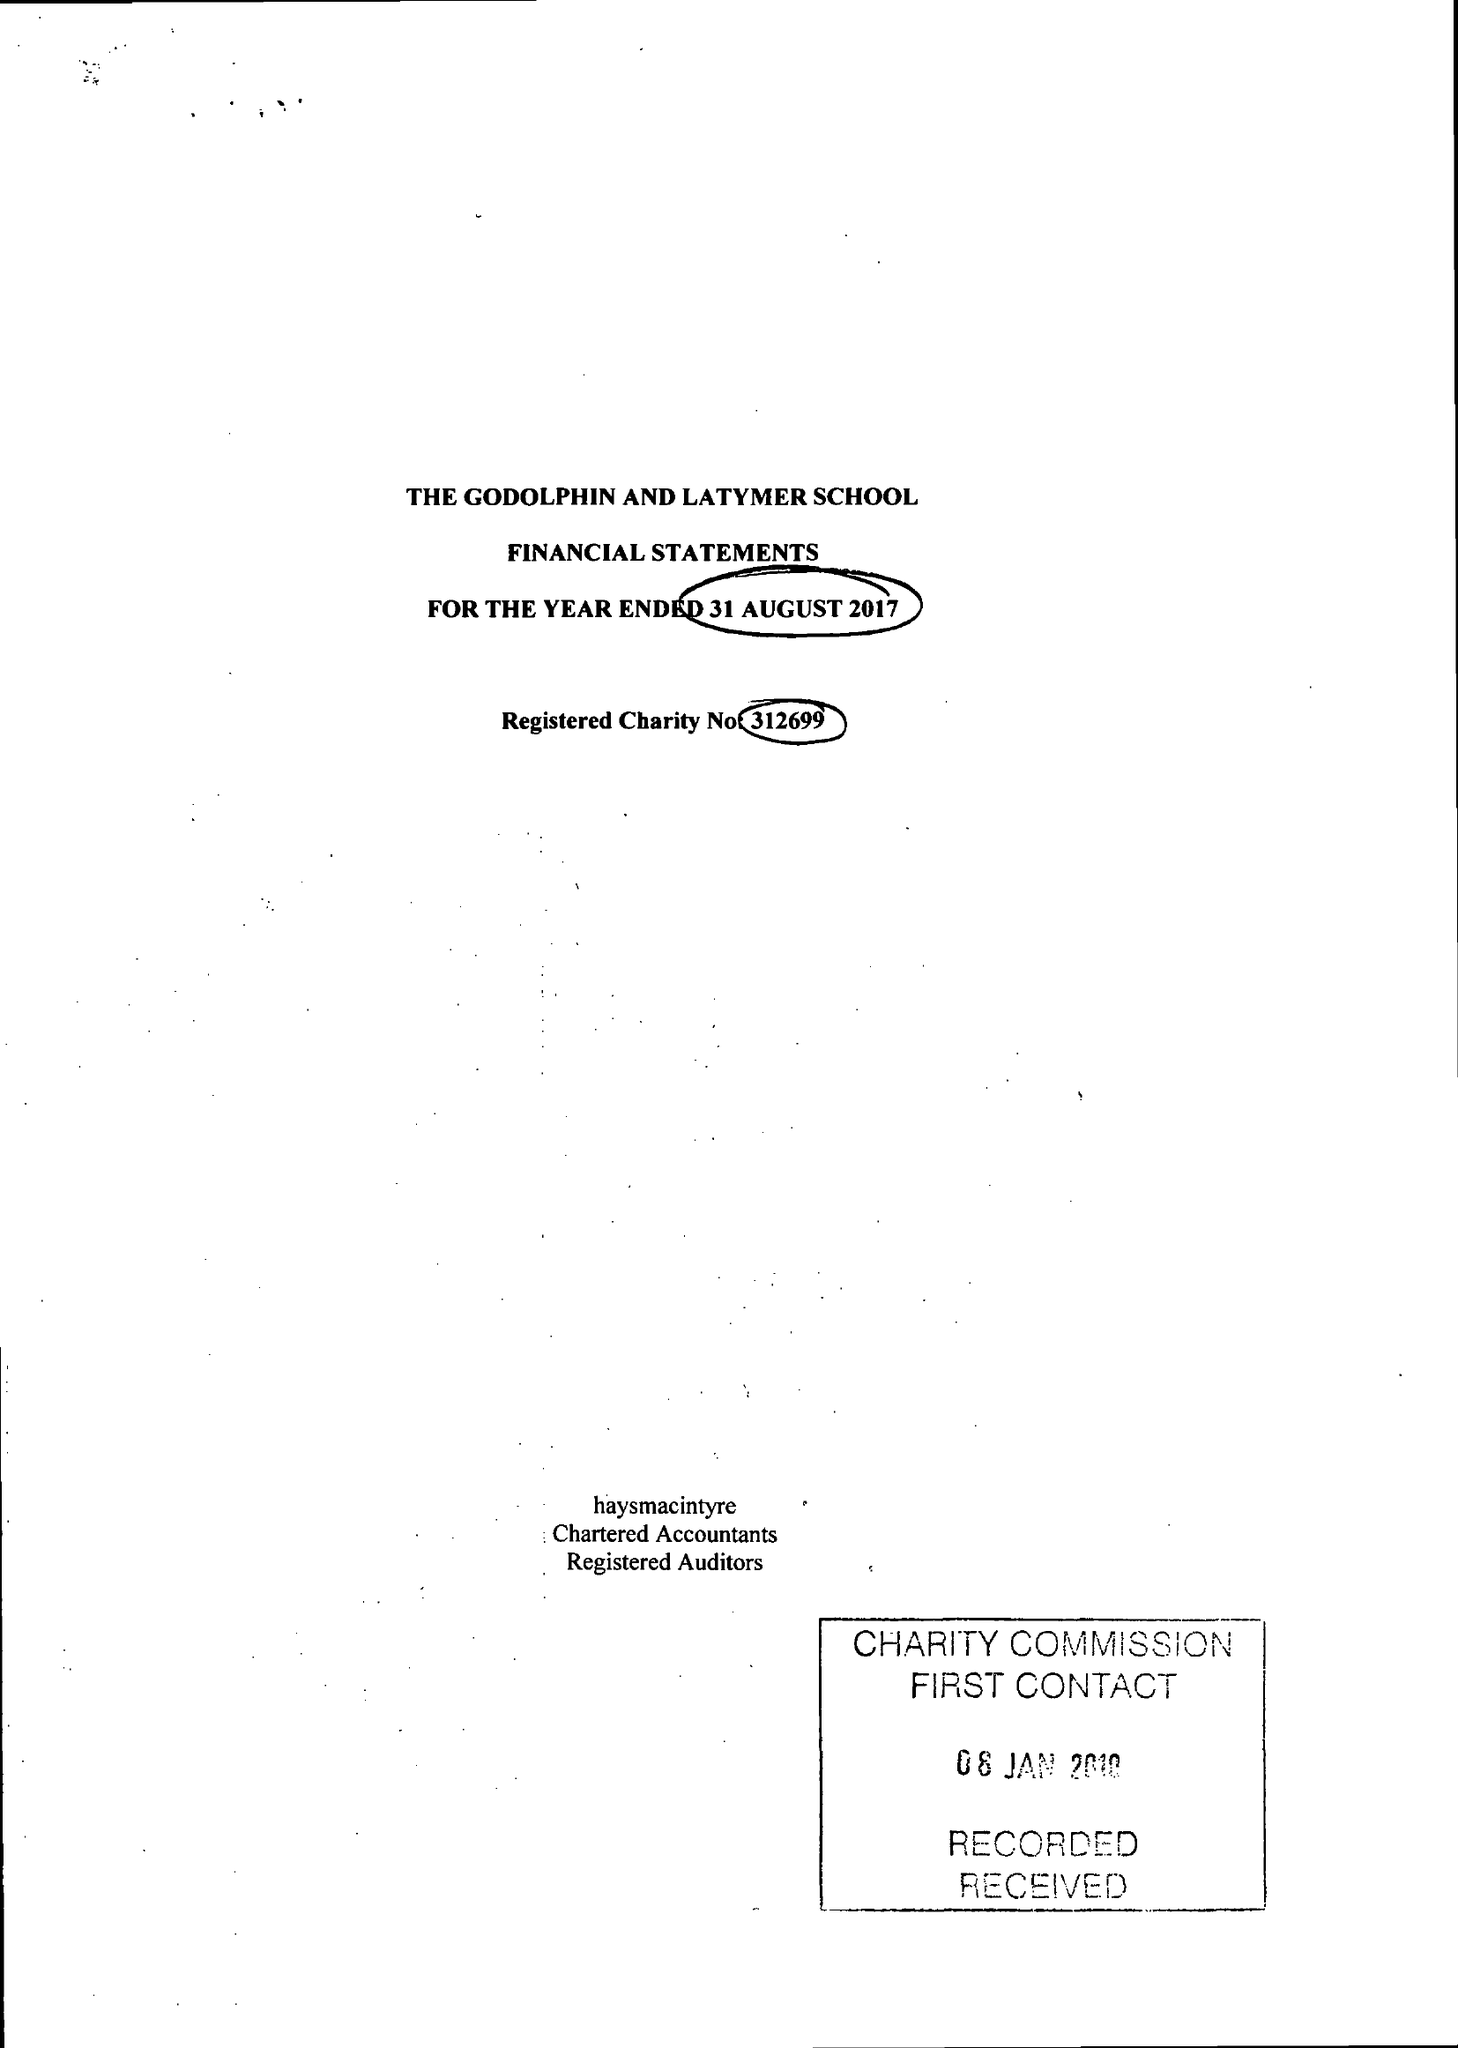What is the value for the spending_annually_in_british_pounds?
Answer the question using a single word or phrase. 15828747.00 